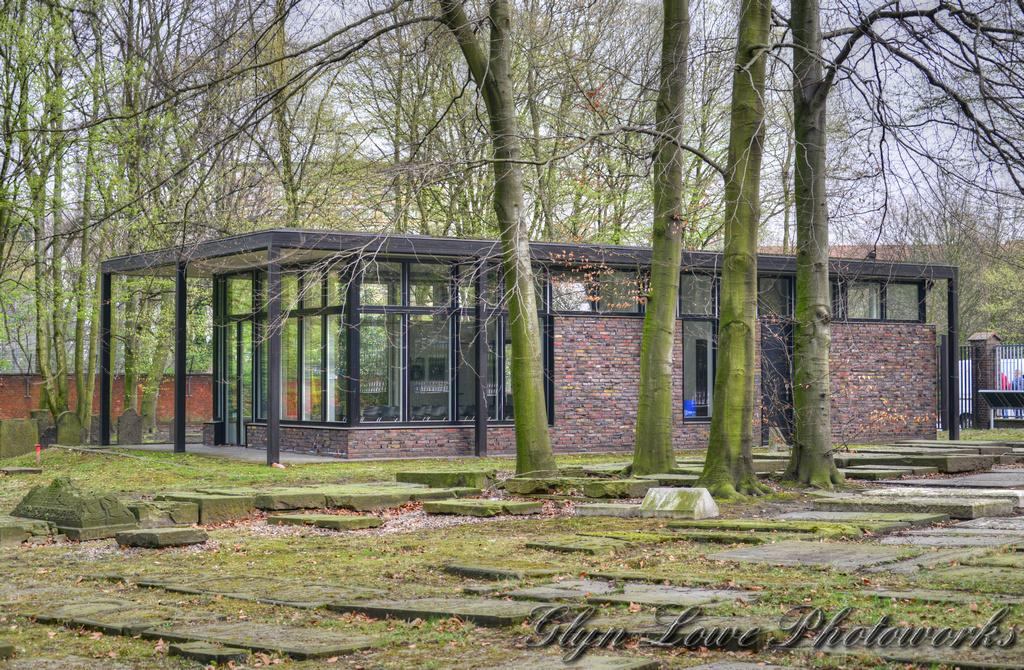What type of structure is present in the image? There is a building in the image. What architectural feature can be seen on the building? There are iron grilles on the building. What type of natural elements are present in the image? There are trees in the image. What can be seen in the background of the image? The sky is visible in the background of the image. Can you see a turkey wearing a glove in the image? No, there is no turkey or glove present in the image. Is there a plane flying in the sky in the image? No, there is no plane visible in the sky in the image. 